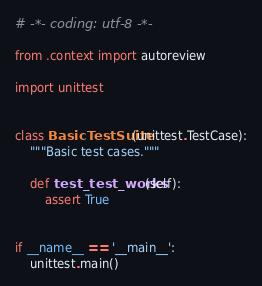<code> <loc_0><loc_0><loc_500><loc_500><_Python_># -*- coding: utf-8 -*-

from .context import autoreview

import unittest


class BasicTestSuite(unittest.TestCase):
    """Basic test cases."""

    def test_test_works(self):
        assert True


if __name__ == '__main__':
    unittest.main()
</code> 